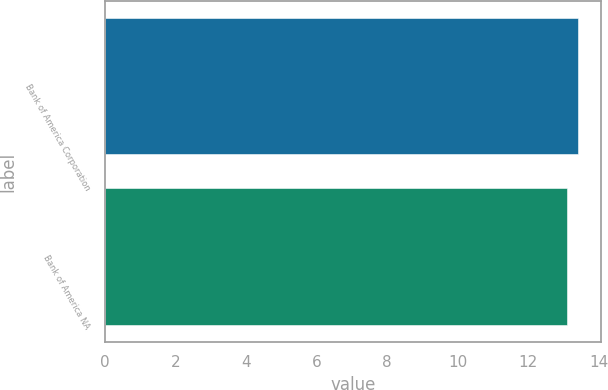Convert chart to OTSL. <chart><loc_0><loc_0><loc_500><loc_500><bar_chart><fcel>Bank of America Corporation<fcel>Bank of America NA<nl><fcel>13.4<fcel>13.1<nl></chart> 